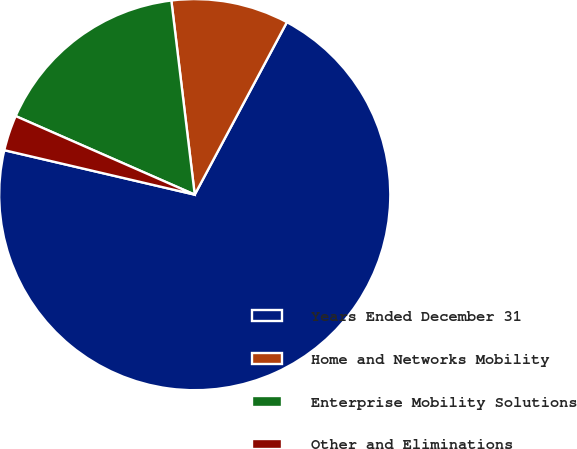Convert chart. <chart><loc_0><loc_0><loc_500><loc_500><pie_chart><fcel>Years Ended December 31<fcel>Home and Networks Mobility<fcel>Enterprise Mobility Solutions<fcel>Other and Eliminations<nl><fcel>70.84%<fcel>9.72%<fcel>16.51%<fcel>2.93%<nl></chart> 